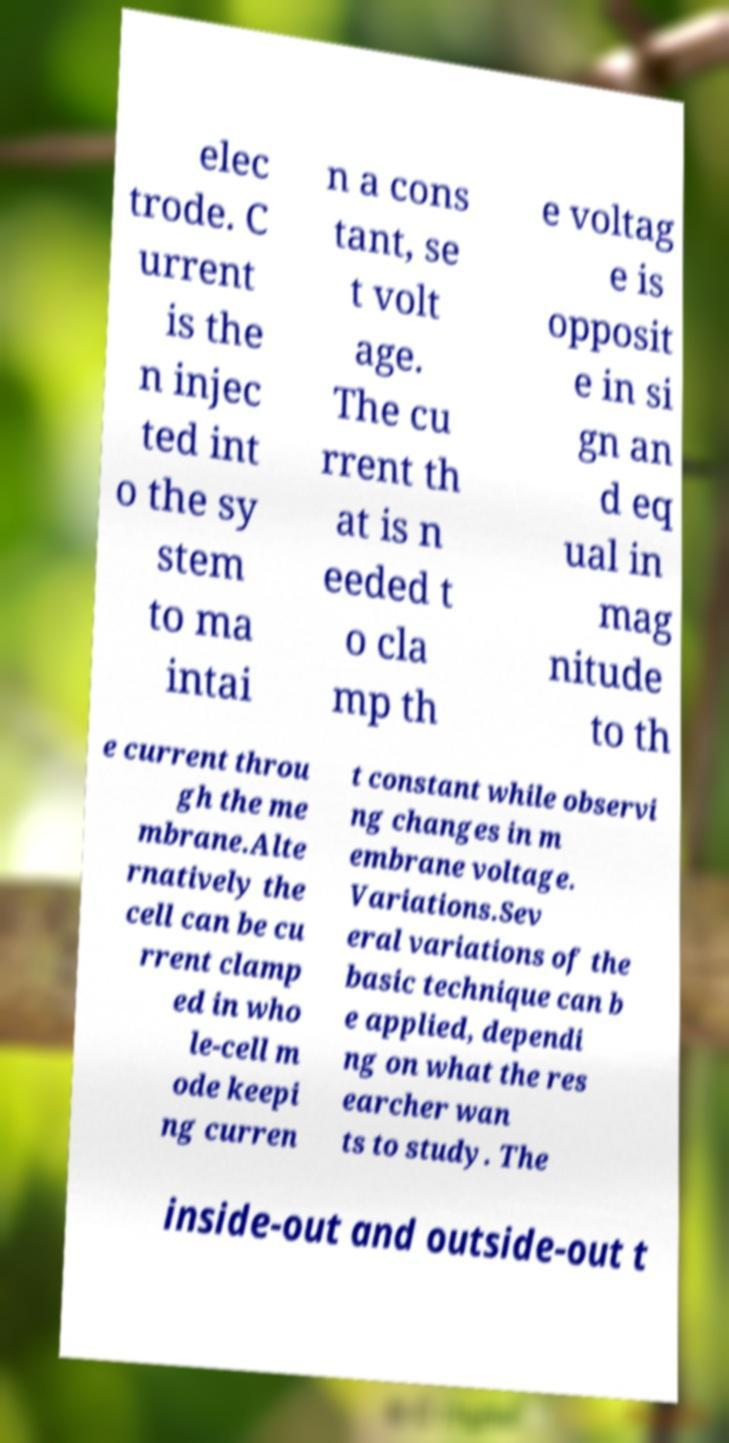What messages or text are displayed in this image? I need them in a readable, typed format. elec trode. C urrent is the n injec ted int o the sy stem to ma intai n a cons tant, se t volt age. The cu rrent th at is n eeded t o cla mp th e voltag e is opposit e in si gn an d eq ual in mag nitude to th e current throu gh the me mbrane.Alte rnatively the cell can be cu rrent clamp ed in who le-cell m ode keepi ng curren t constant while observi ng changes in m embrane voltage. Variations.Sev eral variations of the basic technique can b e applied, dependi ng on what the res earcher wan ts to study. The inside-out and outside-out t 